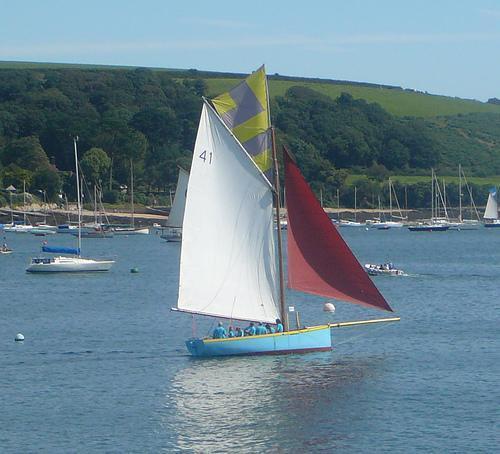How many red sails are there?
Give a very brief answer. 1. 